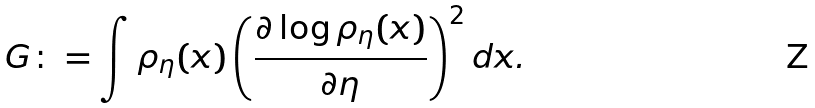<formula> <loc_0><loc_0><loc_500><loc_500>G \colon = \int \rho _ { \eta } ( x ) \left ( \frac { \partial \log \rho _ { \eta } ( x ) } { \partial \eta } \right ) ^ { 2 } d x .</formula> 